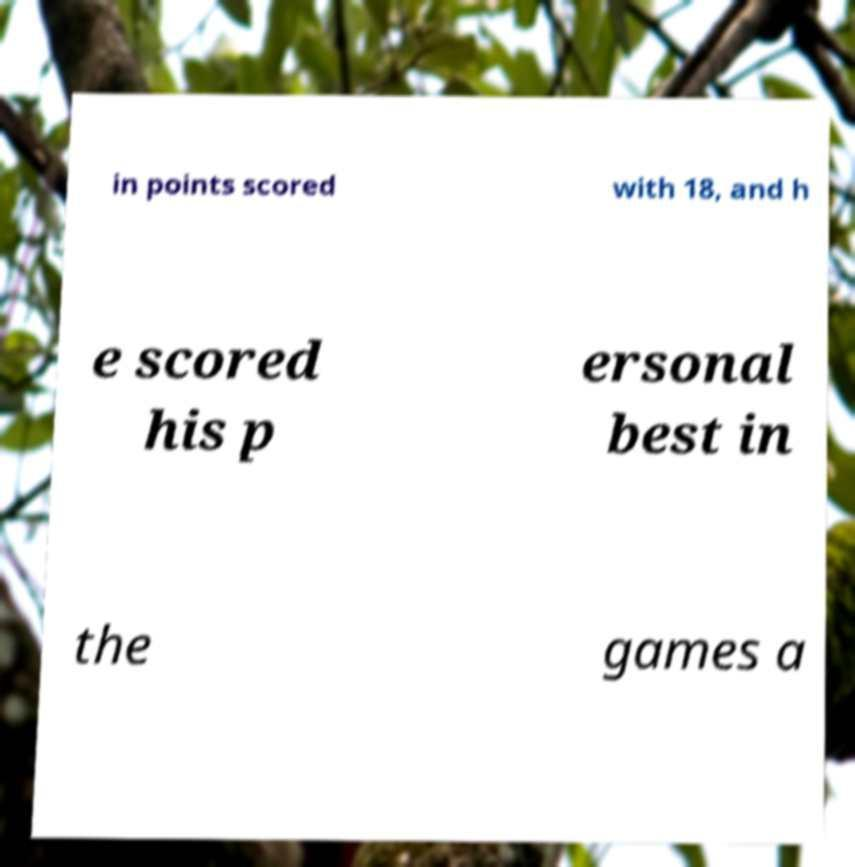Can you read and provide the text displayed in the image?This photo seems to have some interesting text. Can you extract and type it out for me? in points scored with 18, and h e scored his p ersonal best in the games a 